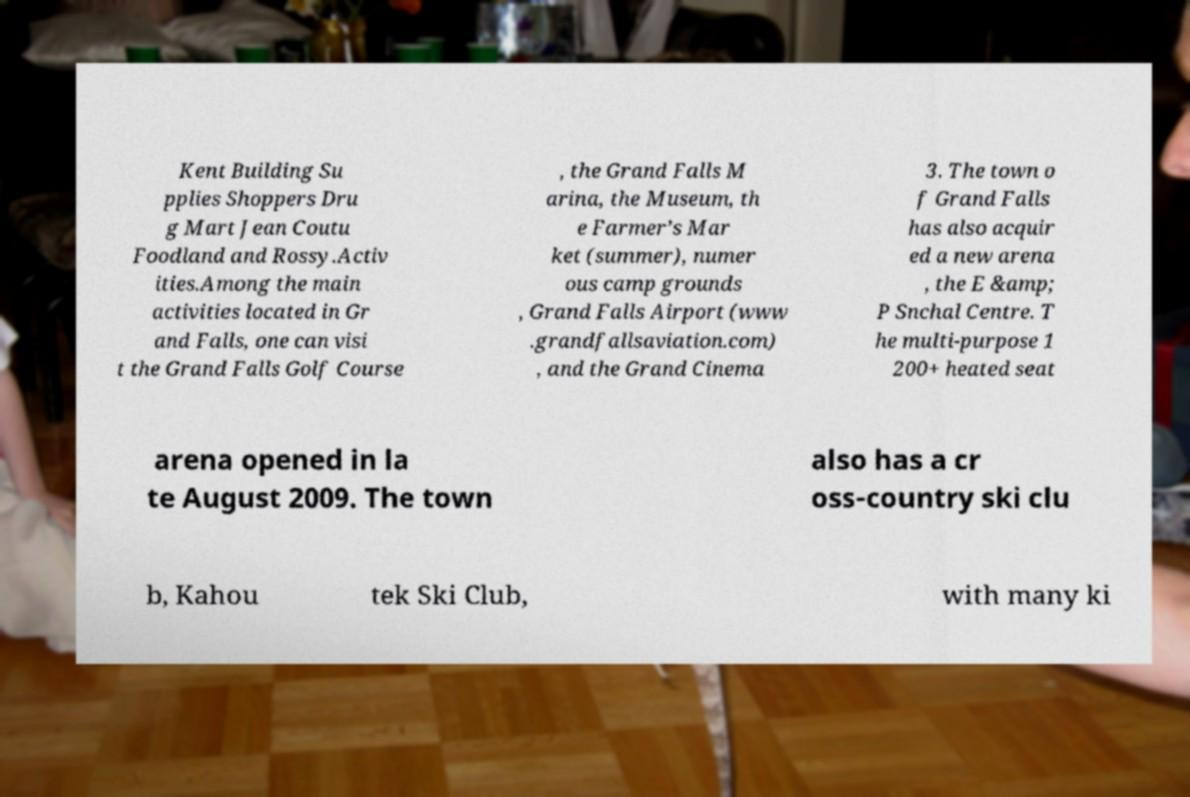For documentation purposes, I need the text within this image transcribed. Could you provide that? Kent Building Su pplies Shoppers Dru g Mart Jean Coutu Foodland and Rossy.Activ ities.Among the main activities located in Gr and Falls, one can visi t the Grand Falls Golf Course , the Grand Falls M arina, the Museum, th e Farmer’s Mar ket (summer), numer ous camp grounds , Grand Falls Airport (www .grandfallsaviation.com) , and the Grand Cinema 3. The town o f Grand Falls has also acquir ed a new arena , the E &amp; P Snchal Centre. T he multi-purpose 1 200+ heated seat arena opened in la te August 2009. The town also has a cr oss-country ski clu b, Kahou tek Ski Club, with many ki 